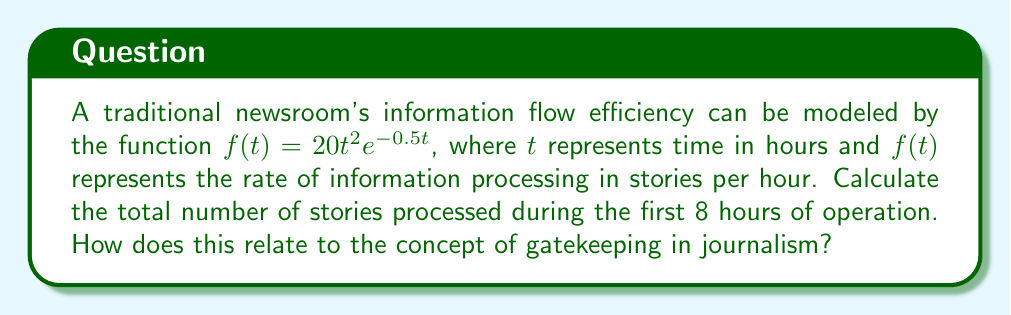Could you help me with this problem? To solve this problem, we need to integrate the given function over the specified time interval. This will give us the total number of stories processed.

1) The integral we need to evaluate is:

   $$\int_0^8 20t^2e^{-0.5t} dt$$

2) This is a complex integral that requires integration by parts. Let's set:
   $u = t^2$ and $dv = 20e^{-0.5t} dt$

3) Then, $du = 2t dt$ and $v = -40e^{-0.5t}$

4) Using the integration by parts formula $\int u dv = uv - \int v du$:

   $$\int_0^8 20t^2e^{-0.5t} dt = [-40t^2e^{-0.5t}]_0^8 + \int_0^8 80te^{-0.5t} dt$$

5) We now need to integrate by parts again for the remaining integral. Let:
   $u = t$ and $dv = 80e^{-0.5t} dt$

6) Then, $du = dt$ and $v = -160e^{-0.5t}$

7) Applying integration by parts again:

   $$\int_0^8 80te^{-0.5t} dt = [-160te^{-0.5t}]_0^8 + \int_0^8 160e^{-0.5t} dt$$

8) The last integral is straightforward:

   $$\int_0^8 160e^{-0.5t} dt = [-320e^{-0.5t}]_0^8$$

9) Putting it all together:

   $$\int_0^8 20t^2e^{-0.5t} dt = [-40t^2e^{-0.5t} - 160te^{-0.5t} - 320e^{-0.5t}]_0^8$$

10) Evaluating at the limits:

    $$= (-40(64)e^{-4} - 160(8)e^{-4} - 320e^{-4}) - (-40(0)e^{0} - 160(0)e^{0} - 320e^{0})$$
    $$= (-2560e^{-4} - 1280e^{-4} - 320e^{-4}) - (-320)$$
    $$= -4160e^{-4} + 320$$
    $$\approx 320 - 76.46 = 243.54$$

This result represents the total number of stories processed in the first 8 hours. The efficiency model shows how information flow starts slow, peaks, and then decreases, which aligns with the gatekeeping concept in journalism. Gatekeeping involves selecting which stories to publish, and this model reflects how that process might vary in efficiency over time.
Answer: Approximately 243.54 stories are processed during the first 8 hours of operation. 